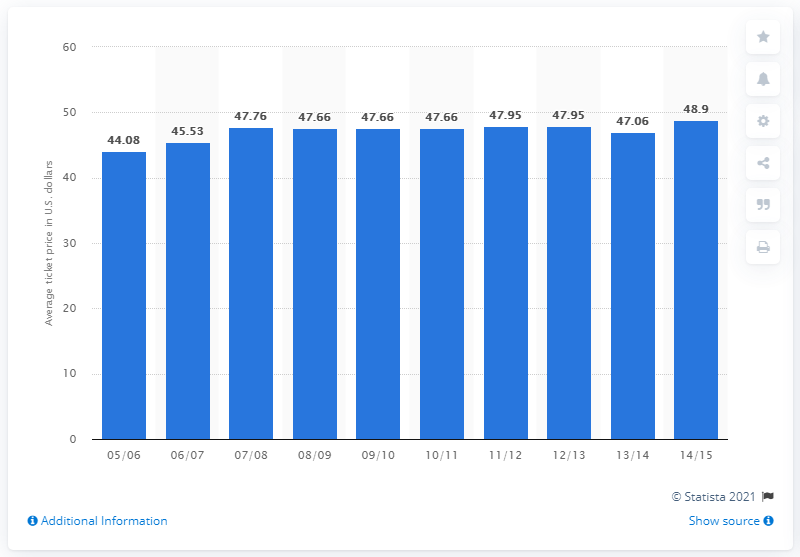Point out several critical features in this image. During the 2005/2006 season, the average ticket price was 44.08 dollars. 